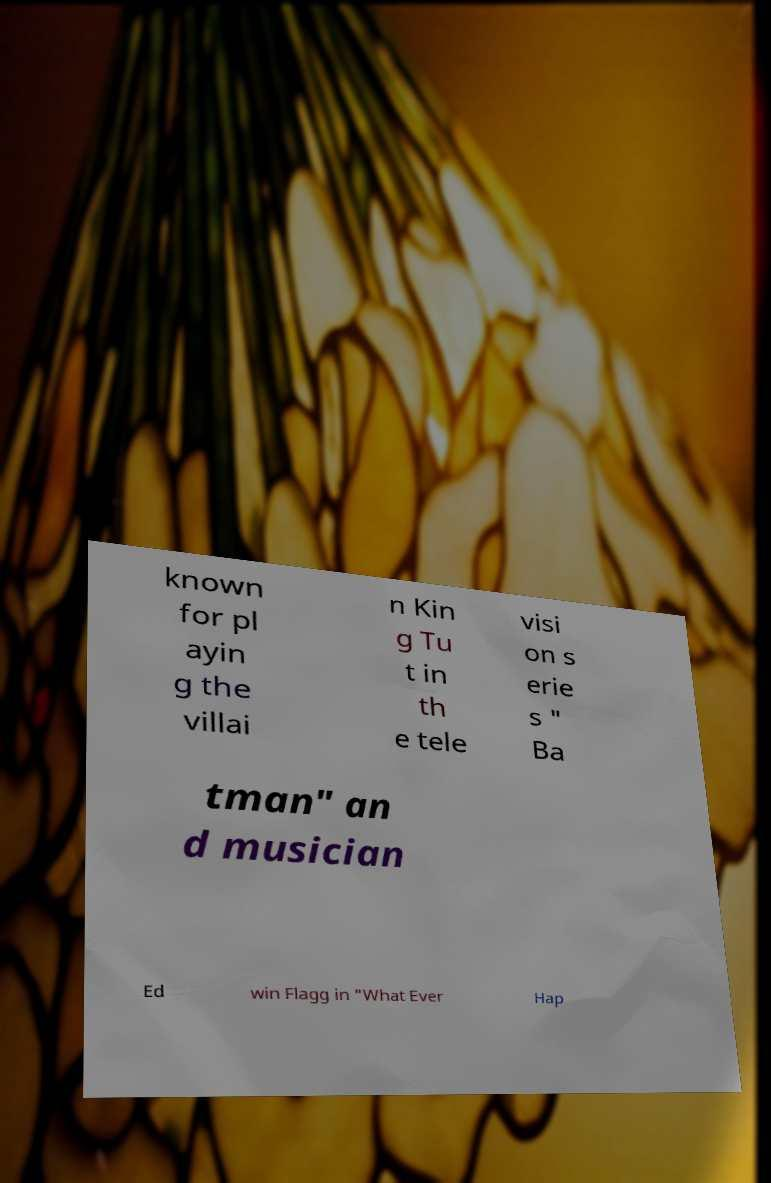Please read and relay the text visible in this image. What does it say? known for pl ayin g the villai n Kin g Tu t in th e tele visi on s erie s " Ba tman" an d musician Ed win Flagg in "What Ever Hap 